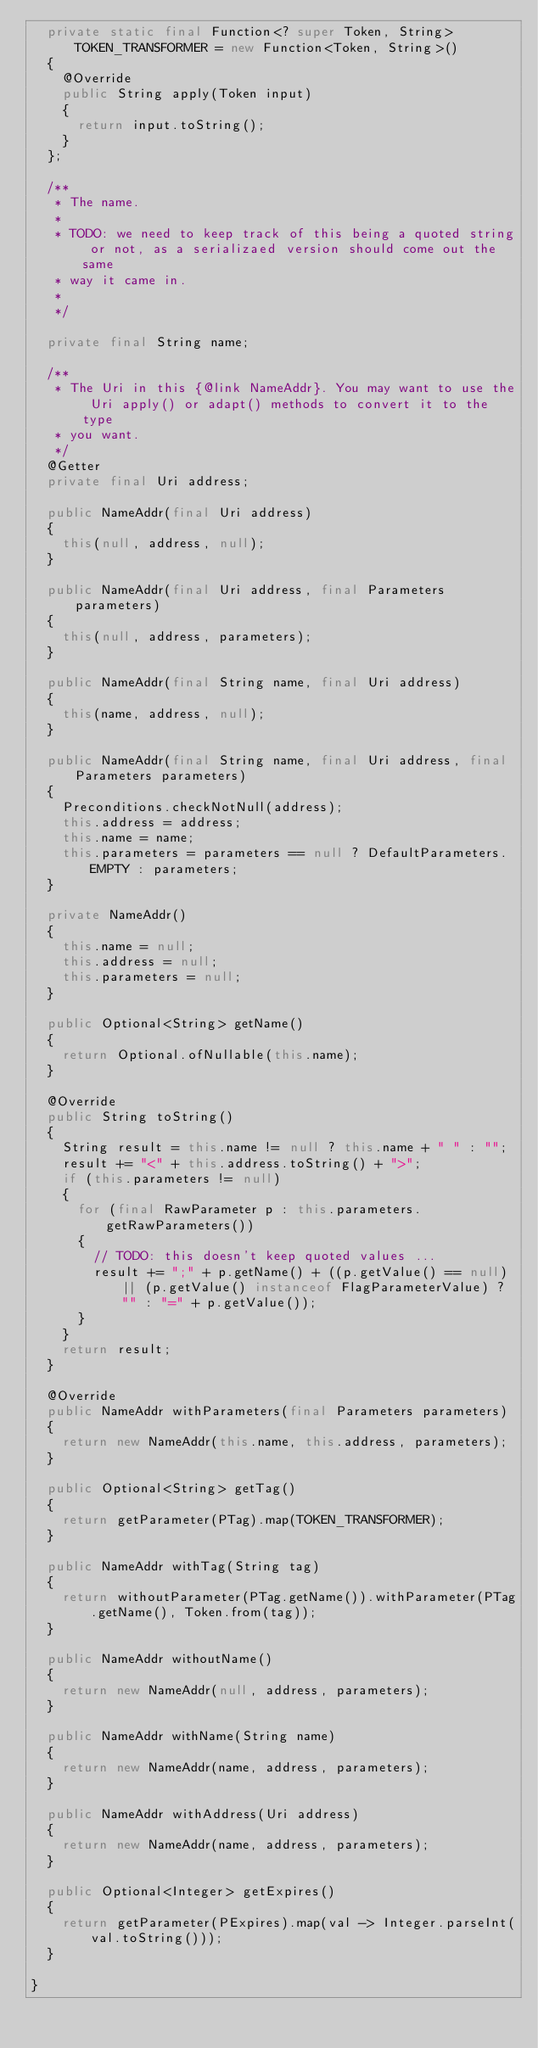<code> <loc_0><loc_0><loc_500><loc_500><_Java_>  private static final Function<? super Token, String> TOKEN_TRANSFORMER = new Function<Token, String>()
  {
    @Override
    public String apply(Token input)
    {
      return input.toString();
    }
  };

  /**
   * The name.
   * 
   * TODO: we need to keep track of this being a quoted string or not, as a serializaed version should come out the same
   * way it came in.
   * 
   */

  private final String name;

  /**
   * The Uri in this {@link NameAddr}. You may want to use the Uri apply() or adapt() methods to convert it to the type
   * you want.
   */
  @Getter
  private final Uri address;

  public NameAddr(final Uri address)
  {
    this(null, address, null);
  }

  public NameAddr(final Uri address, final Parameters parameters)
  {
    this(null, address, parameters);
  }

  public NameAddr(final String name, final Uri address)
  {
    this(name, address, null);
  }

  public NameAddr(final String name, final Uri address, final Parameters parameters)
  {
    Preconditions.checkNotNull(address);
    this.address = address;
    this.name = name;
    this.parameters = parameters == null ? DefaultParameters.EMPTY : parameters;
  }

  private NameAddr()
  {
    this.name = null;
    this.address = null;
    this.parameters = null;
  }

  public Optional<String> getName()
  {
    return Optional.ofNullable(this.name);
  }

  @Override
  public String toString()
  {
    String result = this.name != null ? this.name + " " : "";
    result += "<" + this.address.toString() + ">";
    if (this.parameters != null)
    {
      for (final RawParameter p : this.parameters.getRawParameters())
      {
        // TODO: this doesn't keep quoted values ...
        result += ";" + p.getName() + ((p.getValue() == null) || (p.getValue() instanceof FlagParameterValue) ? "" : "=" + p.getValue());
      }
    }
    return result;
  }

  @Override
  public NameAddr withParameters(final Parameters parameters)
  {
    return new NameAddr(this.name, this.address, parameters);
  }

  public Optional<String> getTag()
  {
    return getParameter(PTag).map(TOKEN_TRANSFORMER);
  }

  public NameAddr withTag(String tag)
  {
    return withoutParameter(PTag.getName()).withParameter(PTag.getName(), Token.from(tag));
  }

  public NameAddr withoutName()
  {
    return new NameAddr(null, address, parameters);
  }

  public NameAddr withName(String name)
  {
    return new NameAddr(name, address, parameters);
  }

  public NameAddr withAddress(Uri address)
  {
    return new NameAddr(name, address, parameters);
  }

  public Optional<Integer> getExpires()
  {
    return getParameter(PExpires).map(val -> Integer.parseInt(val.toString()));
  }

}
</code> 